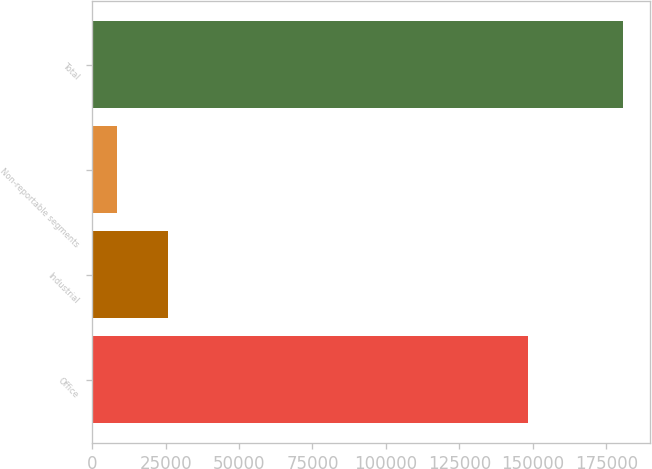<chart> <loc_0><loc_0><loc_500><loc_500><bar_chart><fcel>Office<fcel>Industrial<fcel>Non-reportable segments<fcel>Total<nl><fcel>148493<fcel>25666.2<fcel>8435<fcel>180747<nl></chart> 